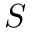Convert formula to latex. <formula><loc_0><loc_0><loc_500><loc_500>S</formula> 